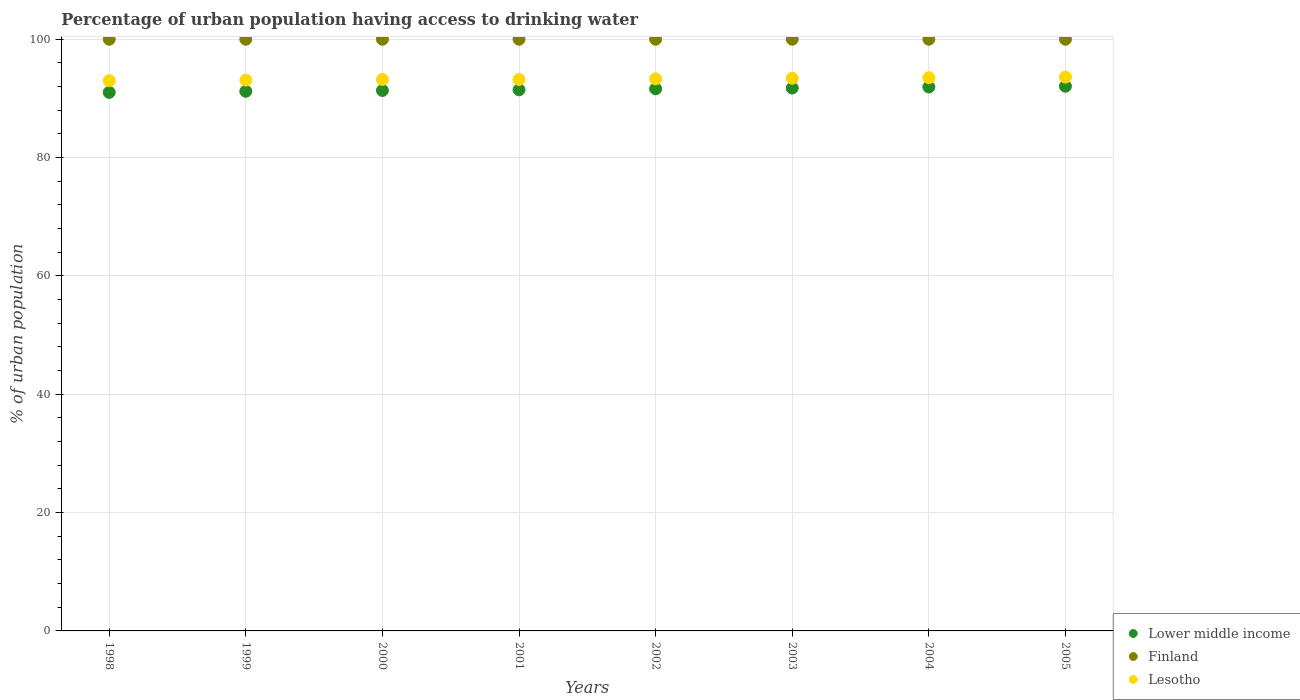How many different coloured dotlines are there?
Your response must be concise. 3. What is the percentage of urban population having access to drinking water in Lesotho in 2003?
Provide a succinct answer. 93.4. Across all years, what is the maximum percentage of urban population having access to drinking water in Lesotho?
Offer a very short reply. 93.6. Across all years, what is the minimum percentage of urban population having access to drinking water in Lesotho?
Provide a short and direct response. 93. In which year was the percentage of urban population having access to drinking water in Lower middle income maximum?
Provide a succinct answer. 2005. In which year was the percentage of urban population having access to drinking water in Lesotho minimum?
Provide a succinct answer. 1998. What is the total percentage of urban population having access to drinking water in Lower middle income in the graph?
Offer a terse response. 732.37. What is the difference between the percentage of urban population having access to drinking water in Lower middle income in 2004 and the percentage of urban population having access to drinking water in Finland in 2001?
Give a very brief answer. -8.08. What is the average percentage of urban population having access to drinking water in Lesotho per year?
Give a very brief answer. 93.29. In the year 2001, what is the difference between the percentage of urban population having access to drinking water in Lesotho and percentage of urban population having access to drinking water in Lower middle income?
Your answer should be compact. 1.74. In how many years, is the percentage of urban population having access to drinking water in Finland greater than 60 %?
Your answer should be compact. 8. What is the ratio of the percentage of urban population having access to drinking water in Lower middle income in 1998 to that in 2004?
Your answer should be compact. 0.99. Is the percentage of urban population having access to drinking water in Lesotho in 1999 less than that in 2002?
Your answer should be very brief. Yes. What is the difference between the highest and the lowest percentage of urban population having access to drinking water in Finland?
Your answer should be compact. 0. Is it the case that in every year, the sum of the percentage of urban population having access to drinking water in Lesotho and percentage of urban population having access to drinking water in Lower middle income  is greater than the percentage of urban population having access to drinking water in Finland?
Keep it short and to the point. Yes. How many dotlines are there?
Your answer should be compact. 3. How many years are there in the graph?
Keep it short and to the point. 8. What is the difference between two consecutive major ticks on the Y-axis?
Give a very brief answer. 20. Are the values on the major ticks of Y-axis written in scientific E-notation?
Provide a short and direct response. No. Where does the legend appear in the graph?
Ensure brevity in your answer.  Bottom right. How many legend labels are there?
Make the answer very short. 3. How are the legend labels stacked?
Your answer should be compact. Vertical. What is the title of the graph?
Your answer should be compact. Percentage of urban population having access to drinking water. Does "Bermuda" appear as one of the legend labels in the graph?
Ensure brevity in your answer.  No. What is the label or title of the X-axis?
Provide a succinct answer. Years. What is the label or title of the Y-axis?
Give a very brief answer. % of urban population. What is the % of urban population in Lower middle income in 1998?
Make the answer very short. 91.02. What is the % of urban population in Finland in 1998?
Your answer should be compact. 100. What is the % of urban population of Lesotho in 1998?
Give a very brief answer. 93. What is the % of urban population in Lower middle income in 1999?
Provide a succinct answer. 91.2. What is the % of urban population in Finland in 1999?
Ensure brevity in your answer.  100. What is the % of urban population in Lesotho in 1999?
Ensure brevity in your answer.  93.1. What is the % of urban population of Lower middle income in 2000?
Ensure brevity in your answer.  91.34. What is the % of urban population in Lesotho in 2000?
Give a very brief answer. 93.2. What is the % of urban population in Lower middle income in 2001?
Provide a succinct answer. 91.46. What is the % of urban population of Lesotho in 2001?
Offer a very short reply. 93.2. What is the % of urban population of Lower middle income in 2002?
Provide a short and direct response. 91.63. What is the % of urban population in Finland in 2002?
Ensure brevity in your answer.  100. What is the % of urban population in Lesotho in 2002?
Your answer should be compact. 93.3. What is the % of urban population in Lower middle income in 2003?
Your response must be concise. 91.75. What is the % of urban population in Finland in 2003?
Offer a very short reply. 100. What is the % of urban population in Lesotho in 2003?
Your response must be concise. 93.4. What is the % of urban population in Lower middle income in 2004?
Offer a very short reply. 91.92. What is the % of urban population in Lesotho in 2004?
Provide a succinct answer. 93.5. What is the % of urban population of Lower middle income in 2005?
Your answer should be very brief. 92.05. What is the % of urban population of Lesotho in 2005?
Your answer should be compact. 93.6. Across all years, what is the maximum % of urban population in Lower middle income?
Give a very brief answer. 92.05. Across all years, what is the maximum % of urban population in Lesotho?
Your answer should be very brief. 93.6. Across all years, what is the minimum % of urban population of Lower middle income?
Keep it short and to the point. 91.02. Across all years, what is the minimum % of urban population in Finland?
Provide a succinct answer. 100. Across all years, what is the minimum % of urban population in Lesotho?
Provide a succinct answer. 93. What is the total % of urban population of Lower middle income in the graph?
Your response must be concise. 732.37. What is the total % of urban population of Finland in the graph?
Provide a succinct answer. 800. What is the total % of urban population of Lesotho in the graph?
Keep it short and to the point. 746.3. What is the difference between the % of urban population in Lower middle income in 1998 and that in 1999?
Provide a succinct answer. -0.18. What is the difference between the % of urban population of Finland in 1998 and that in 1999?
Make the answer very short. 0. What is the difference between the % of urban population of Lesotho in 1998 and that in 1999?
Provide a short and direct response. -0.1. What is the difference between the % of urban population of Lower middle income in 1998 and that in 2000?
Your answer should be very brief. -0.32. What is the difference between the % of urban population in Lesotho in 1998 and that in 2000?
Keep it short and to the point. -0.2. What is the difference between the % of urban population in Lower middle income in 1998 and that in 2001?
Your answer should be compact. -0.44. What is the difference between the % of urban population of Lesotho in 1998 and that in 2001?
Offer a terse response. -0.2. What is the difference between the % of urban population in Lower middle income in 1998 and that in 2002?
Offer a terse response. -0.61. What is the difference between the % of urban population in Lower middle income in 1998 and that in 2003?
Provide a succinct answer. -0.74. What is the difference between the % of urban population of Lesotho in 1998 and that in 2003?
Offer a very short reply. -0.4. What is the difference between the % of urban population of Lower middle income in 1998 and that in 2004?
Offer a very short reply. -0.91. What is the difference between the % of urban population in Lower middle income in 1998 and that in 2005?
Provide a short and direct response. -1.04. What is the difference between the % of urban population in Lower middle income in 1999 and that in 2000?
Keep it short and to the point. -0.14. What is the difference between the % of urban population of Lower middle income in 1999 and that in 2001?
Ensure brevity in your answer.  -0.26. What is the difference between the % of urban population of Finland in 1999 and that in 2001?
Ensure brevity in your answer.  0. What is the difference between the % of urban population in Lesotho in 1999 and that in 2001?
Keep it short and to the point. -0.1. What is the difference between the % of urban population in Lower middle income in 1999 and that in 2002?
Your answer should be compact. -0.42. What is the difference between the % of urban population in Lower middle income in 1999 and that in 2003?
Keep it short and to the point. -0.55. What is the difference between the % of urban population in Finland in 1999 and that in 2003?
Provide a short and direct response. 0. What is the difference between the % of urban population in Lesotho in 1999 and that in 2003?
Your response must be concise. -0.3. What is the difference between the % of urban population of Lower middle income in 1999 and that in 2004?
Give a very brief answer. -0.72. What is the difference between the % of urban population of Finland in 1999 and that in 2004?
Offer a very short reply. 0. What is the difference between the % of urban population in Lower middle income in 1999 and that in 2005?
Offer a terse response. -0.85. What is the difference between the % of urban population of Lower middle income in 2000 and that in 2001?
Make the answer very short. -0.12. What is the difference between the % of urban population in Lower middle income in 2000 and that in 2002?
Your response must be concise. -0.29. What is the difference between the % of urban population in Finland in 2000 and that in 2002?
Make the answer very short. 0. What is the difference between the % of urban population in Lower middle income in 2000 and that in 2003?
Your response must be concise. -0.42. What is the difference between the % of urban population in Lesotho in 2000 and that in 2003?
Your response must be concise. -0.2. What is the difference between the % of urban population in Lower middle income in 2000 and that in 2004?
Provide a succinct answer. -0.59. What is the difference between the % of urban population in Lesotho in 2000 and that in 2004?
Ensure brevity in your answer.  -0.3. What is the difference between the % of urban population of Lower middle income in 2000 and that in 2005?
Give a very brief answer. -0.72. What is the difference between the % of urban population of Finland in 2000 and that in 2005?
Ensure brevity in your answer.  0. What is the difference between the % of urban population in Lesotho in 2000 and that in 2005?
Offer a very short reply. -0.4. What is the difference between the % of urban population of Lower middle income in 2001 and that in 2002?
Provide a short and direct response. -0.17. What is the difference between the % of urban population in Finland in 2001 and that in 2002?
Keep it short and to the point. 0. What is the difference between the % of urban population in Lower middle income in 2001 and that in 2003?
Provide a succinct answer. -0.29. What is the difference between the % of urban population of Lesotho in 2001 and that in 2003?
Give a very brief answer. -0.2. What is the difference between the % of urban population of Lower middle income in 2001 and that in 2004?
Your answer should be compact. -0.46. What is the difference between the % of urban population of Lower middle income in 2001 and that in 2005?
Give a very brief answer. -0.59. What is the difference between the % of urban population in Finland in 2001 and that in 2005?
Give a very brief answer. 0. What is the difference between the % of urban population in Lesotho in 2001 and that in 2005?
Offer a terse response. -0.4. What is the difference between the % of urban population in Lower middle income in 2002 and that in 2003?
Your answer should be compact. -0.13. What is the difference between the % of urban population in Finland in 2002 and that in 2003?
Offer a terse response. 0. What is the difference between the % of urban population of Lesotho in 2002 and that in 2003?
Offer a very short reply. -0.1. What is the difference between the % of urban population in Lower middle income in 2002 and that in 2004?
Provide a succinct answer. -0.3. What is the difference between the % of urban population of Lower middle income in 2002 and that in 2005?
Ensure brevity in your answer.  -0.43. What is the difference between the % of urban population in Lower middle income in 2003 and that in 2004?
Provide a succinct answer. -0.17. What is the difference between the % of urban population of Lower middle income in 2003 and that in 2005?
Offer a terse response. -0.3. What is the difference between the % of urban population in Lower middle income in 2004 and that in 2005?
Provide a short and direct response. -0.13. What is the difference between the % of urban population in Lesotho in 2004 and that in 2005?
Keep it short and to the point. -0.1. What is the difference between the % of urban population of Lower middle income in 1998 and the % of urban population of Finland in 1999?
Provide a short and direct response. -8.98. What is the difference between the % of urban population of Lower middle income in 1998 and the % of urban population of Lesotho in 1999?
Offer a terse response. -2.08. What is the difference between the % of urban population in Finland in 1998 and the % of urban population in Lesotho in 1999?
Give a very brief answer. 6.9. What is the difference between the % of urban population of Lower middle income in 1998 and the % of urban population of Finland in 2000?
Your response must be concise. -8.98. What is the difference between the % of urban population of Lower middle income in 1998 and the % of urban population of Lesotho in 2000?
Give a very brief answer. -2.18. What is the difference between the % of urban population in Finland in 1998 and the % of urban population in Lesotho in 2000?
Your answer should be compact. 6.8. What is the difference between the % of urban population in Lower middle income in 1998 and the % of urban population in Finland in 2001?
Offer a very short reply. -8.98. What is the difference between the % of urban population in Lower middle income in 1998 and the % of urban population in Lesotho in 2001?
Give a very brief answer. -2.18. What is the difference between the % of urban population in Finland in 1998 and the % of urban population in Lesotho in 2001?
Keep it short and to the point. 6.8. What is the difference between the % of urban population of Lower middle income in 1998 and the % of urban population of Finland in 2002?
Make the answer very short. -8.98. What is the difference between the % of urban population of Lower middle income in 1998 and the % of urban population of Lesotho in 2002?
Offer a terse response. -2.28. What is the difference between the % of urban population in Lower middle income in 1998 and the % of urban population in Finland in 2003?
Offer a terse response. -8.98. What is the difference between the % of urban population of Lower middle income in 1998 and the % of urban population of Lesotho in 2003?
Ensure brevity in your answer.  -2.38. What is the difference between the % of urban population of Lower middle income in 1998 and the % of urban population of Finland in 2004?
Ensure brevity in your answer.  -8.98. What is the difference between the % of urban population of Lower middle income in 1998 and the % of urban population of Lesotho in 2004?
Give a very brief answer. -2.48. What is the difference between the % of urban population in Finland in 1998 and the % of urban population in Lesotho in 2004?
Your answer should be very brief. 6.5. What is the difference between the % of urban population in Lower middle income in 1998 and the % of urban population in Finland in 2005?
Provide a succinct answer. -8.98. What is the difference between the % of urban population in Lower middle income in 1998 and the % of urban population in Lesotho in 2005?
Make the answer very short. -2.58. What is the difference between the % of urban population in Lower middle income in 1999 and the % of urban population in Finland in 2000?
Provide a short and direct response. -8.8. What is the difference between the % of urban population of Lower middle income in 1999 and the % of urban population of Lesotho in 2000?
Keep it short and to the point. -2. What is the difference between the % of urban population in Lower middle income in 1999 and the % of urban population in Finland in 2001?
Your answer should be compact. -8.8. What is the difference between the % of urban population in Lower middle income in 1999 and the % of urban population in Lesotho in 2001?
Your answer should be very brief. -2. What is the difference between the % of urban population of Finland in 1999 and the % of urban population of Lesotho in 2001?
Provide a succinct answer. 6.8. What is the difference between the % of urban population in Lower middle income in 1999 and the % of urban population in Finland in 2002?
Provide a short and direct response. -8.8. What is the difference between the % of urban population of Lower middle income in 1999 and the % of urban population of Lesotho in 2002?
Offer a very short reply. -2.1. What is the difference between the % of urban population in Lower middle income in 1999 and the % of urban population in Finland in 2003?
Offer a very short reply. -8.8. What is the difference between the % of urban population of Lower middle income in 1999 and the % of urban population of Lesotho in 2003?
Make the answer very short. -2.2. What is the difference between the % of urban population of Finland in 1999 and the % of urban population of Lesotho in 2003?
Offer a terse response. 6.6. What is the difference between the % of urban population of Lower middle income in 1999 and the % of urban population of Finland in 2004?
Your answer should be compact. -8.8. What is the difference between the % of urban population in Lower middle income in 1999 and the % of urban population in Lesotho in 2004?
Make the answer very short. -2.3. What is the difference between the % of urban population in Finland in 1999 and the % of urban population in Lesotho in 2004?
Offer a terse response. 6.5. What is the difference between the % of urban population of Lower middle income in 1999 and the % of urban population of Finland in 2005?
Make the answer very short. -8.8. What is the difference between the % of urban population of Lower middle income in 1999 and the % of urban population of Lesotho in 2005?
Your response must be concise. -2.4. What is the difference between the % of urban population of Finland in 1999 and the % of urban population of Lesotho in 2005?
Your answer should be very brief. 6.4. What is the difference between the % of urban population in Lower middle income in 2000 and the % of urban population in Finland in 2001?
Keep it short and to the point. -8.66. What is the difference between the % of urban population in Lower middle income in 2000 and the % of urban population in Lesotho in 2001?
Your answer should be compact. -1.86. What is the difference between the % of urban population in Finland in 2000 and the % of urban population in Lesotho in 2001?
Keep it short and to the point. 6.8. What is the difference between the % of urban population in Lower middle income in 2000 and the % of urban population in Finland in 2002?
Make the answer very short. -8.66. What is the difference between the % of urban population of Lower middle income in 2000 and the % of urban population of Lesotho in 2002?
Provide a succinct answer. -1.96. What is the difference between the % of urban population in Finland in 2000 and the % of urban population in Lesotho in 2002?
Offer a very short reply. 6.7. What is the difference between the % of urban population of Lower middle income in 2000 and the % of urban population of Finland in 2003?
Give a very brief answer. -8.66. What is the difference between the % of urban population of Lower middle income in 2000 and the % of urban population of Lesotho in 2003?
Ensure brevity in your answer.  -2.06. What is the difference between the % of urban population of Lower middle income in 2000 and the % of urban population of Finland in 2004?
Your answer should be very brief. -8.66. What is the difference between the % of urban population of Lower middle income in 2000 and the % of urban population of Lesotho in 2004?
Provide a succinct answer. -2.16. What is the difference between the % of urban population in Lower middle income in 2000 and the % of urban population in Finland in 2005?
Your answer should be compact. -8.66. What is the difference between the % of urban population in Lower middle income in 2000 and the % of urban population in Lesotho in 2005?
Ensure brevity in your answer.  -2.26. What is the difference between the % of urban population in Lower middle income in 2001 and the % of urban population in Finland in 2002?
Your answer should be compact. -8.54. What is the difference between the % of urban population in Lower middle income in 2001 and the % of urban population in Lesotho in 2002?
Provide a succinct answer. -1.84. What is the difference between the % of urban population of Lower middle income in 2001 and the % of urban population of Finland in 2003?
Ensure brevity in your answer.  -8.54. What is the difference between the % of urban population in Lower middle income in 2001 and the % of urban population in Lesotho in 2003?
Offer a terse response. -1.94. What is the difference between the % of urban population in Lower middle income in 2001 and the % of urban population in Finland in 2004?
Your answer should be very brief. -8.54. What is the difference between the % of urban population in Lower middle income in 2001 and the % of urban population in Lesotho in 2004?
Your answer should be compact. -2.04. What is the difference between the % of urban population in Lower middle income in 2001 and the % of urban population in Finland in 2005?
Offer a terse response. -8.54. What is the difference between the % of urban population of Lower middle income in 2001 and the % of urban population of Lesotho in 2005?
Ensure brevity in your answer.  -2.14. What is the difference between the % of urban population in Lower middle income in 2002 and the % of urban population in Finland in 2003?
Keep it short and to the point. -8.37. What is the difference between the % of urban population of Lower middle income in 2002 and the % of urban population of Lesotho in 2003?
Your answer should be very brief. -1.77. What is the difference between the % of urban population of Finland in 2002 and the % of urban population of Lesotho in 2003?
Provide a short and direct response. 6.6. What is the difference between the % of urban population of Lower middle income in 2002 and the % of urban population of Finland in 2004?
Provide a short and direct response. -8.37. What is the difference between the % of urban population of Lower middle income in 2002 and the % of urban population of Lesotho in 2004?
Ensure brevity in your answer.  -1.87. What is the difference between the % of urban population in Lower middle income in 2002 and the % of urban population in Finland in 2005?
Ensure brevity in your answer.  -8.37. What is the difference between the % of urban population of Lower middle income in 2002 and the % of urban population of Lesotho in 2005?
Provide a short and direct response. -1.97. What is the difference between the % of urban population in Lower middle income in 2003 and the % of urban population in Finland in 2004?
Provide a succinct answer. -8.25. What is the difference between the % of urban population in Lower middle income in 2003 and the % of urban population in Lesotho in 2004?
Offer a very short reply. -1.75. What is the difference between the % of urban population of Finland in 2003 and the % of urban population of Lesotho in 2004?
Your answer should be compact. 6.5. What is the difference between the % of urban population in Lower middle income in 2003 and the % of urban population in Finland in 2005?
Provide a succinct answer. -8.25. What is the difference between the % of urban population in Lower middle income in 2003 and the % of urban population in Lesotho in 2005?
Offer a very short reply. -1.85. What is the difference between the % of urban population of Lower middle income in 2004 and the % of urban population of Finland in 2005?
Ensure brevity in your answer.  -8.08. What is the difference between the % of urban population in Lower middle income in 2004 and the % of urban population in Lesotho in 2005?
Offer a very short reply. -1.68. What is the average % of urban population of Lower middle income per year?
Your answer should be compact. 91.55. What is the average % of urban population of Lesotho per year?
Keep it short and to the point. 93.29. In the year 1998, what is the difference between the % of urban population of Lower middle income and % of urban population of Finland?
Make the answer very short. -8.98. In the year 1998, what is the difference between the % of urban population of Lower middle income and % of urban population of Lesotho?
Your answer should be compact. -1.98. In the year 1999, what is the difference between the % of urban population of Lower middle income and % of urban population of Finland?
Your answer should be very brief. -8.8. In the year 1999, what is the difference between the % of urban population in Lower middle income and % of urban population in Lesotho?
Make the answer very short. -1.9. In the year 1999, what is the difference between the % of urban population in Finland and % of urban population in Lesotho?
Offer a terse response. 6.9. In the year 2000, what is the difference between the % of urban population in Lower middle income and % of urban population in Finland?
Provide a short and direct response. -8.66. In the year 2000, what is the difference between the % of urban population in Lower middle income and % of urban population in Lesotho?
Offer a terse response. -1.86. In the year 2000, what is the difference between the % of urban population in Finland and % of urban population in Lesotho?
Provide a short and direct response. 6.8. In the year 2001, what is the difference between the % of urban population of Lower middle income and % of urban population of Finland?
Your answer should be very brief. -8.54. In the year 2001, what is the difference between the % of urban population of Lower middle income and % of urban population of Lesotho?
Give a very brief answer. -1.74. In the year 2002, what is the difference between the % of urban population of Lower middle income and % of urban population of Finland?
Your answer should be very brief. -8.37. In the year 2002, what is the difference between the % of urban population of Lower middle income and % of urban population of Lesotho?
Provide a succinct answer. -1.67. In the year 2003, what is the difference between the % of urban population of Lower middle income and % of urban population of Finland?
Your response must be concise. -8.25. In the year 2003, what is the difference between the % of urban population in Lower middle income and % of urban population in Lesotho?
Give a very brief answer. -1.65. In the year 2003, what is the difference between the % of urban population in Finland and % of urban population in Lesotho?
Provide a succinct answer. 6.6. In the year 2004, what is the difference between the % of urban population of Lower middle income and % of urban population of Finland?
Ensure brevity in your answer.  -8.08. In the year 2004, what is the difference between the % of urban population in Lower middle income and % of urban population in Lesotho?
Make the answer very short. -1.58. In the year 2004, what is the difference between the % of urban population of Finland and % of urban population of Lesotho?
Offer a very short reply. 6.5. In the year 2005, what is the difference between the % of urban population of Lower middle income and % of urban population of Finland?
Keep it short and to the point. -7.95. In the year 2005, what is the difference between the % of urban population of Lower middle income and % of urban population of Lesotho?
Your response must be concise. -1.55. What is the ratio of the % of urban population of Lower middle income in 1998 to that in 1999?
Give a very brief answer. 1. What is the ratio of the % of urban population in Finland in 1998 to that in 1999?
Ensure brevity in your answer.  1. What is the ratio of the % of urban population of Lower middle income in 1998 to that in 2000?
Keep it short and to the point. 1. What is the ratio of the % of urban population of Finland in 1998 to that in 2001?
Give a very brief answer. 1. What is the ratio of the % of urban population in Lower middle income in 1998 to that in 2002?
Your answer should be very brief. 0.99. What is the ratio of the % of urban population in Finland in 1998 to that in 2002?
Offer a terse response. 1. What is the ratio of the % of urban population in Lesotho in 1998 to that in 2002?
Offer a terse response. 1. What is the ratio of the % of urban population in Lower middle income in 1998 to that in 2003?
Keep it short and to the point. 0.99. What is the ratio of the % of urban population of Finland in 1998 to that in 2003?
Give a very brief answer. 1. What is the ratio of the % of urban population in Lower middle income in 1998 to that in 2004?
Provide a short and direct response. 0.99. What is the ratio of the % of urban population of Lesotho in 1998 to that in 2004?
Offer a very short reply. 0.99. What is the ratio of the % of urban population of Lower middle income in 1998 to that in 2005?
Provide a succinct answer. 0.99. What is the ratio of the % of urban population in Finland in 1998 to that in 2005?
Make the answer very short. 1. What is the ratio of the % of urban population of Lesotho in 1998 to that in 2005?
Offer a very short reply. 0.99. What is the ratio of the % of urban population of Lesotho in 1999 to that in 2000?
Make the answer very short. 1. What is the ratio of the % of urban population of Lower middle income in 1999 to that in 2001?
Your answer should be very brief. 1. What is the ratio of the % of urban population of Finland in 1999 to that in 2001?
Keep it short and to the point. 1. What is the ratio of the % of urban population of Lesotho in 1999 to that in 2001?
Your response must be concise. 1. What is the ratio of the % of urban population of Finland in 1999 to that in 2002?
Your answer should be compact. 1. What is the ratio of the % of urban population of Lesotho in 1999 to that in 2002?
Offer a very short reply. 1. What is the ratio of the % of urban population of Lower middle income in 1999 to that in 2003?
Offer a very short reply. 0.99. What is the ratio of the % of urban population in Lesotho in 1999 to that in 2003?
Ensure brevity in your answer.  1. What is the ratio of the % of urban population of Lower middle income in 1999 to that in 2004?
Provide a short and direct response. 0.99. What is the ratio of the % of urban population in Lesotho in 1999 to that in 2004?
Your answer should be compact. 1. What is the ratio of the % of urban population of Lower middle income in 1999 to that in 2005?
Your response must be concise. 0.99. What is the ratio of the % of urban population of Lesotho in 1999 to that in 2005?
Give a very brief answer. 0.99. What is the ratio of the % of urban population in Finland in 2000 to that in 2001?
Make the answer very short. 1. What is the ratio of the % of urban population of Lower middle income in 2000 to that in 2003?
Provide a short and direct response. 1. What is the ratio of the % of urban population in Lower middle income in 2000 to that in 2004?
Make the answer very short. 0.99. What is the ratio of the % of urban population of Finland in 2000 to that in 2004?
Offer a terse response. 1. What is the ratio of the % of urban population in Finland in 2000 to that in 2005?
Provide a short and direct response. 1. What is the ratio of the % of urban population in Lower middle income in 2001 to that in 2002?
Your answer should be very brief. 1. What is the ratio of the % of urban population in Lower middle income in 2001 to that in 2003?
Offer a very short reply. 1. What is the ratio of the % of urban population of Lesotho in 2001 to that in 2003?
Your answer should be very brief. 1. What is the ratio of the % of urban population of Lower middle income in 2001 to that in 2004?
Give a very brief answer. 0.99. What is the ratio of the % of urban population in Finland in 2001 to that in 2004?
Give a very brief answer. 1. What is the ratio of the % of urban population of Lesotho in 2001 to that in 2004?
Provide a short and direct response. 1. What is the ratio of the % of urban population in Finland in 2001 to that in 2005?
Offer a terse response. 1. What is the ratio of the % of urban population of Lower middle income in 2002 to that in 2003?
Offer a terse response. 1. What is the ratio of the % of urban population of Finland in 2002 to that in 2003?
Your response must be concise. 1. What is the ratio of the % of urban population of Lesotho in 2002 to that in 2003?
Your response must be concise. 1. What is the ratio of the % of urban population in Lesotho in 2002 to that in 2004?
Provide a succinct answer. 1. What is the ratio of the % of urban population of Lesotho in 2002 to that in 2005?
Make the answer very short. 1. What is the ratio of the % of urban population of Lower middle income in 2003 to that in 2004?
Offer a terse response. 1. What is the ratio of the % of urban population of Finland in 2003 to that in 2004?
Your answer should be very brief. 1. What is the ratio of the % of urban population of Lesotho in 2003 to that in 2004?
Your answer should be very brief. 1. What is the ratio of the % of urban population in Lower middle income in 2003 to that in 2005?
Your answer should be very brief. 1. What is the ratio of the % of urban population in Finland in 2003 to that in 2005?
Keep it short and to the point. 1. What is the ratio of the % of urban population of Lower middle income in 2004 to that in 2005?
Offer a terse response. 1. What is the ratio of the % of urban population in Finland in 2004 to that in 2005?
Keep it short and to the point. 1. What is the difference between the highest and the second highest % of urban population of Lower middle income?
Your answer should be very brief. 0.13. What is the difference between the highest and the second highest % of urban population of Lesotho?
Keep it short and to the point. 0.1. What is the difference between the highest and the lowest % of urban population of Lower middle income?
Ensure brevity in your answer.  1.04. What is the difference between the highest and the lowest % of urban population of Finland?
Offer a terse response. 0. What is the difference between the highest and the lowest % of urban population in Lesotho?
Make the answer very short. 0.6. 